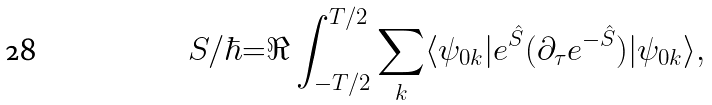<formula> <loc_0><loc_0><loc_500><loc_500>S / \hbar { = } \Re \int _ { - T / 2 } ^ { T / 2 } \sum _ { k } \langle \psi _ { 0 k } | e ^ { \hat { S } } ( \partial _ { \tau } e ^ { - { \hat { S } } } ) | \psi _ { 0 k } \rangle ,</formula> 